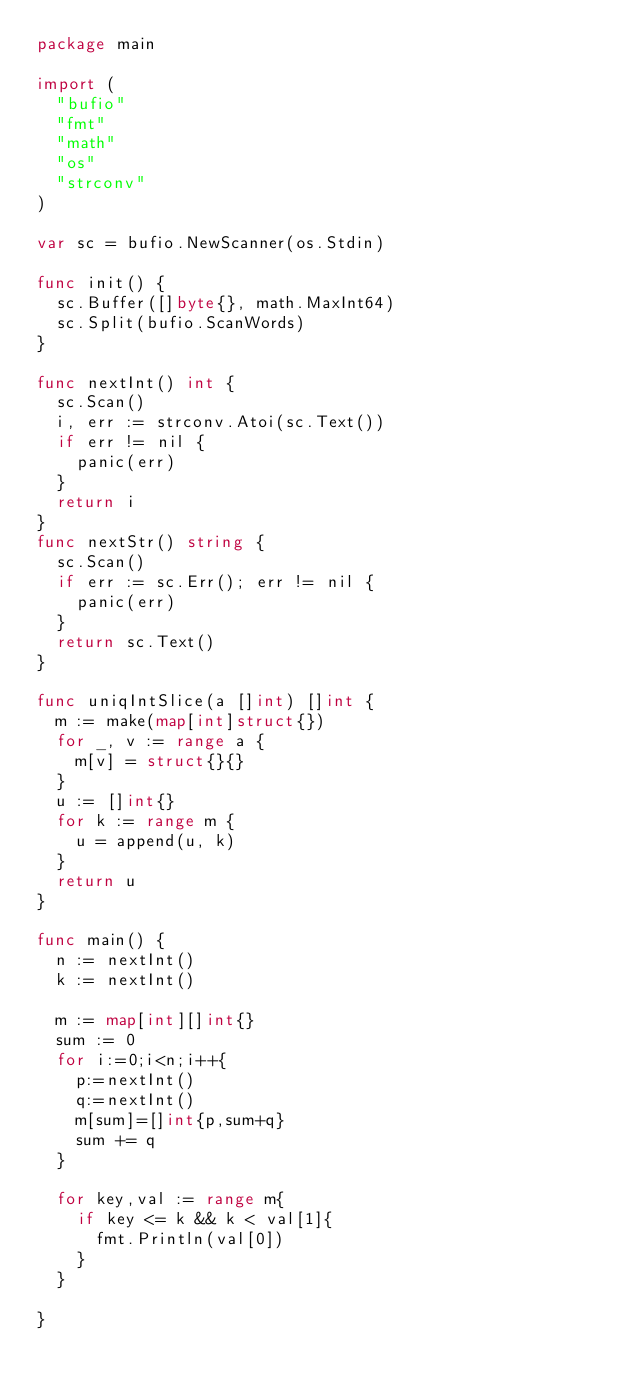Convert code to text. <code><loc_0><loc_0><loc_500><loc_500><_Go_>package main

import (
	"bufio"
	"fmt"
	"math"
	"os"
	"strconv"
)

var sc = bufio.NewScanner(os.Stdin)

func init() {
	sc.Buffer([]byte{}, math.MaxInt64)
	sc.Split(bufio.ScanWords)
}

func nextInt() int {
	sc.Scan()
	i, err := strconv.Atoi(sc.Text())
	if err != nil {
		panic(err)
	}
	return i
}
func nextStr() string {
	sc.Scan()
	if err := sc.Err(); err != nil {
		panic(err)
	}
	return sc.Text()
}

func uniqIntSlice(a []int) []int {
	m := make(map[int]struct{})
	for _, v := range a {
		m[v] = struct{}{}
	}
	u := []int{}
	for k := range m {
		u = append(u, k)
	}
	return u
}

func main() {
	n := nextInt()
	k := nextInt()

	m := map[int][]int{}
	sum := 0
	for i:=0;i<n;i++{
		p:=nextInt()
		q:=nextInt()
		m[sum]=[]int{p,sum+q}
		sum += q
	}

	for key,val := range m{
		if key <= k && k < val[1]{
			fmt.Println(val[0])
		}
	}

}</code> 